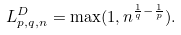<formula> <loc_0><loc_0><loc_500><loc_500>L ^ { D } _ { p , q , n } = \max ( 1 , n ^ { \frac { 1 } { q } - \frac { 1 } { p } } ) .</formula> 